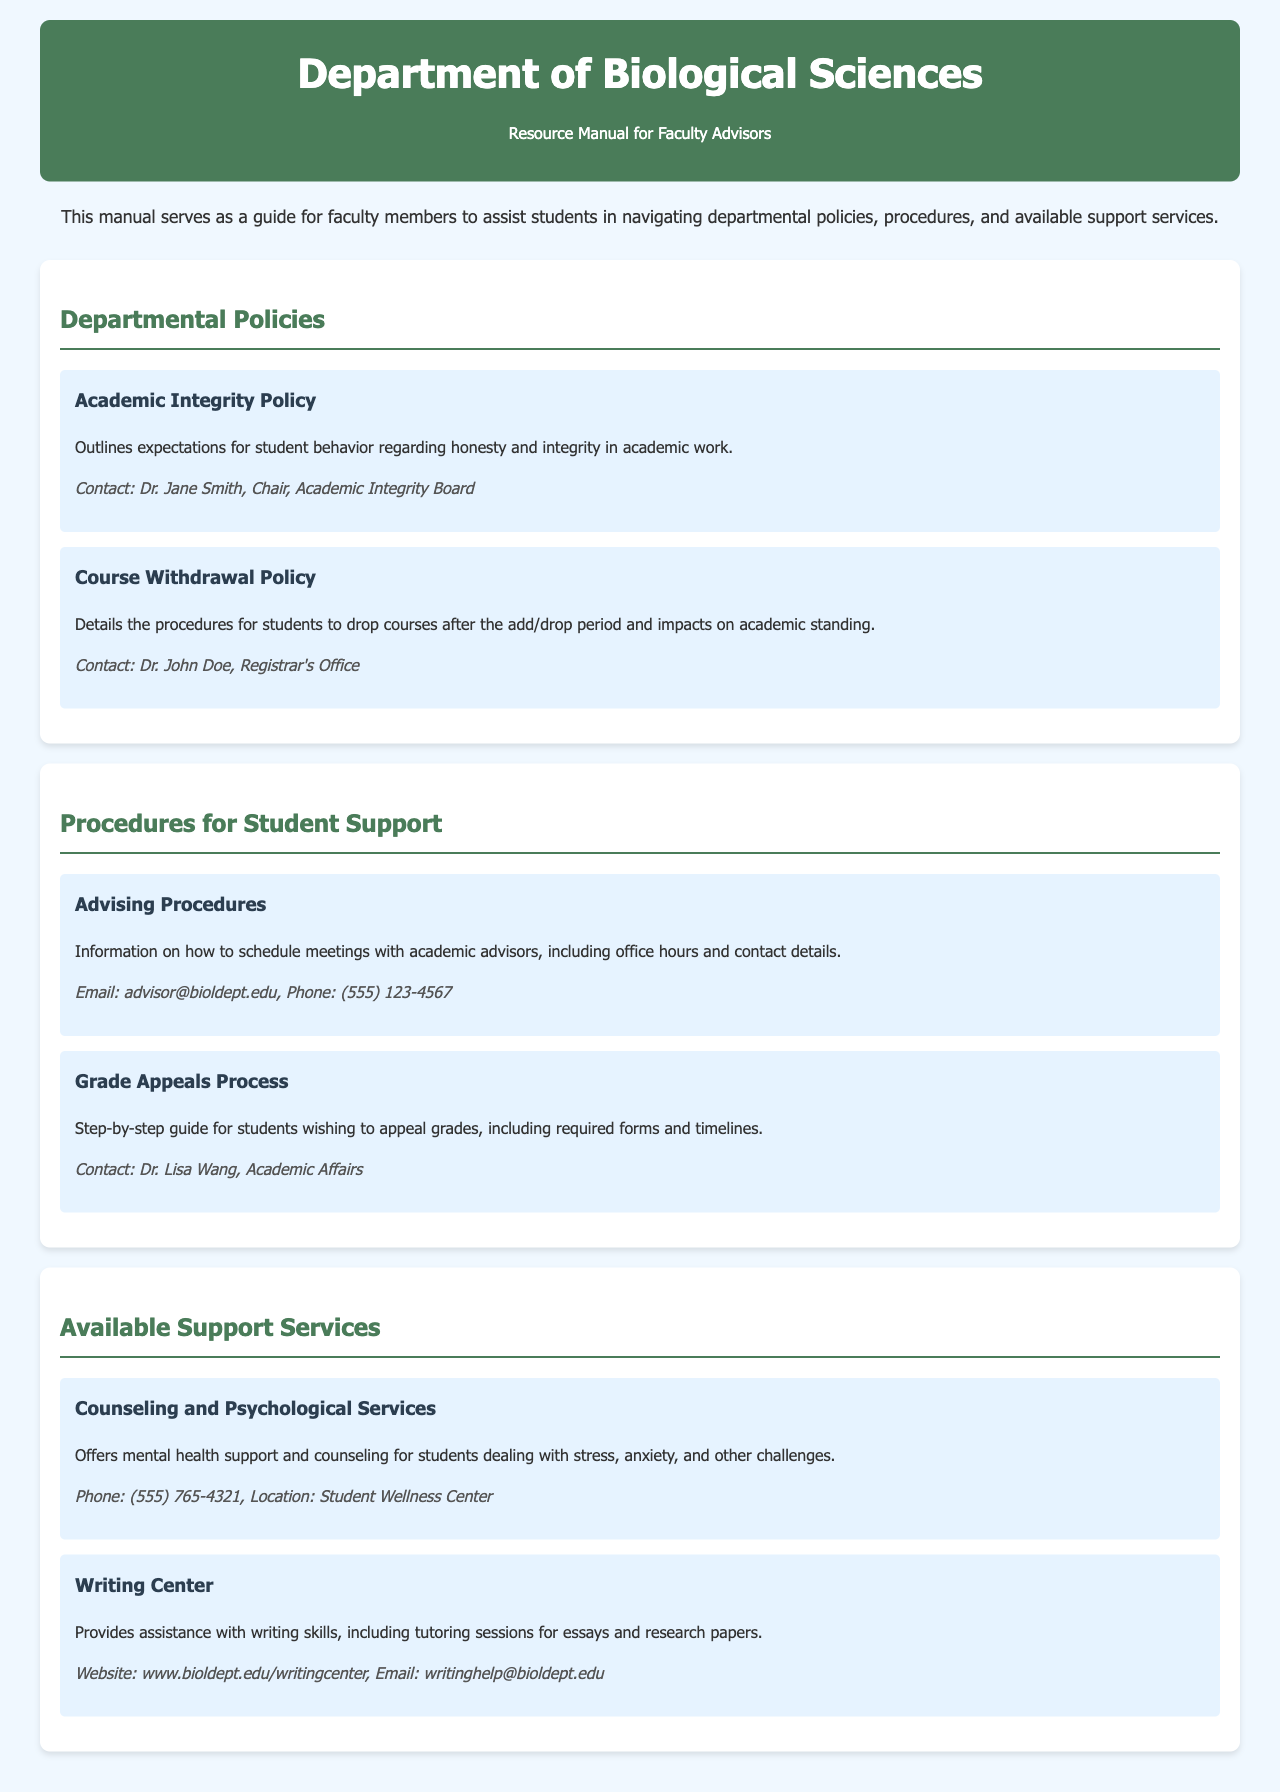What is the title of the manual? The title of the manual is displayed prominently in the header section and provides the main subject of the document.
Answer: Department of Biological Sciences Resource Manual Who is the contact for the Academic Integrity Policy? The document specifies contact details for each policy, procedure, and service, indicating who to reach out for more information.
Answer: Dr. Jane Smith What is the phone number for Counseling and Psychological Services? The document provides specific contact information for each support service, including phone numbers for quick access.
Answer: (555) 765-4321 What is outlined in the Course Withdrawal Policy? This policy describes procedures and implications regarding dropping courses, which is essential information for students managing their academic paths.
Answer: Procedures for students to drop courses after the add/drop period and impacts on academic standing How can students schedule meetings with academic advisors? The document includes procedures that guide students on how to access support services effectively, including making appointments with academic advisors.
Answer: Information on how to schedule meetings with academic advisors What kind of support does the Writing Center provide? The Writing Center's purpose is summarized to give an overview of its function as a resource for students needing assistance with writing.
Answer: Assistance with writing skills, including tutoring sessions for essays and research papers Who is responsible for the Grade Appeals Process? The manual lists contacts for specific processes, highlighting who oversees each area for student inquiries or concerns.
Answer: Dr. Lisa Wang What is included in the introduction of the manual? The introduction provides context and purpose for the manual, setting the tone for its use by faculty advisors.
Answer: A guide for faculty members to assist students in navigating departmental policies, procedures, and available support services 